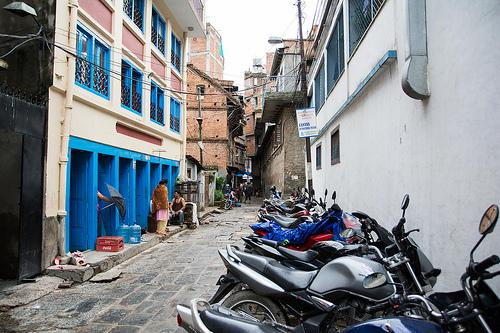Count the number of motorcycles seen in the image. There are 8 motorcycles parked in a row. Describe the state of the sidewalk in the image. The sidewalk appears cracked, dilapidated, and has two large water bottles on it. Identify any visible building features and their colors in the image. A red brick building, a building with blue doors and trim, a blue and white sign, a cream-colored pipe, and a building without paint. Explain the situation with the umbrella in the image. A person is opening an umbrella from their door, and another lady is holding an umbrella on the sidewalk. Describe the interaction between the people on the sidewalk. A group of people are speaking, mingling, and discussing outside a house on the sidewalk. What does the red and white object on the ground seem to be? The red and white object appears to be a pair of crates stacked on the ground. Provide a brief description of the wall mounted street light. A black, metal street light is mounted on a wall near the top left corner of the image. What type of weather is evident in this image? The weather appears to be clear with a bright blue sky. In the image, mention two objects related to electricity. A wooden electrical pole and a bunch of hanging electrical wires. Can you identify the type of road present in the image? The road is a gray stone and cobblestone road. Is there a green door on the building at X:67 Y:130? The door is actually blue, not green. This can confuse the viewer and make them question the color of the door. Are the two large water bottles at X:113 Y:217 orange in color? The color of the water bottles is not mentioned. This question introduces a false attribute, leading the viewer to question the color of the water bottles. Do you see a cat sitting next to the person at X:146 Y:155? There is no mention of a cat in the list of objects. This could lead the viewer to search for a nonexistent animal in the image. Is there a tree beside the electrical pole at X:288 Y:8? There is no mention of a tree in the list of objects. Asking about a nonexistent object could confuse the viewer and make them question their understanding of the image. Can you find a car parked near the motorcycles at X:197 Y:163? There is no mention of a car in the list of objects, only motorcycles. This could lead the viewer to search for a nonexistent object in the image. Can you spot a white umbrella being opened at X:95 Y:180? The umbrella in the image is not described as being white. This false attribute can lead the viewer to question the color of the umbrella and introduce doubt about their interpretation of the image. 